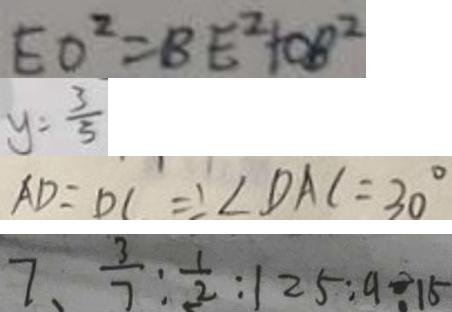Convert formula to latex. <formula><loc_0><loc_0><loc_500><loc_500>E O ^ { 2 } = B E ^ { 2 } + O B ^ { 2 } 
 y = \frac { 3 } { 5 } 
 A D = D C \Rightarrow \angle D A C = 3 0 ^ { \circ } 
 7 、 \frac { 3 } { 7 } : \frac { 1 } { 2 } : 1 2 5 : 9 \div 1 5</formula> 